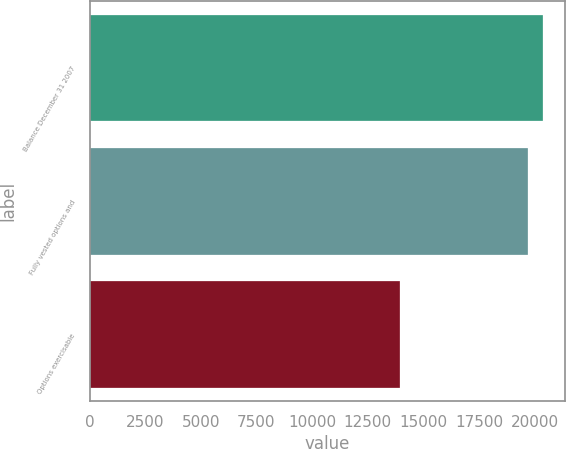<chart> <loc_0><loc_0><loc_500><loc_500><bar_chart><fcel>Balance December 31 2007<fcel>Fully vested options and<fcel>Options exercisable<nl><fcel>20365<fcel>19720<fcel>13953<nl></chart> 